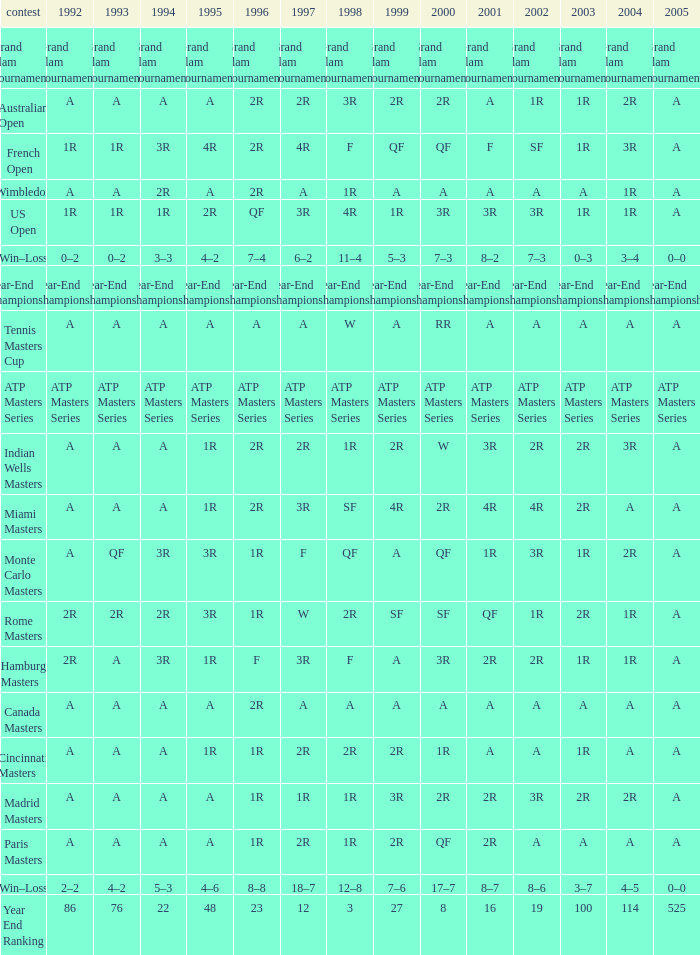What is 2005, when 1998 is "F", and when 2002 is "2R"? A. 